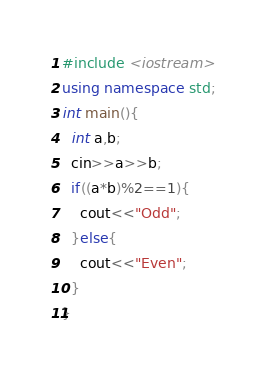Convert code to text. <code><loc_0><loc_0><loc_500><loc_500><_C++_>#include <iostream>
using namespace std;
int main(){
  int a,b;
  cin>>a>>b;
  if((a*b)%2==1){
    cout<<"Odd";
  }else{
    cout<<"Even";
  }
}</code> 